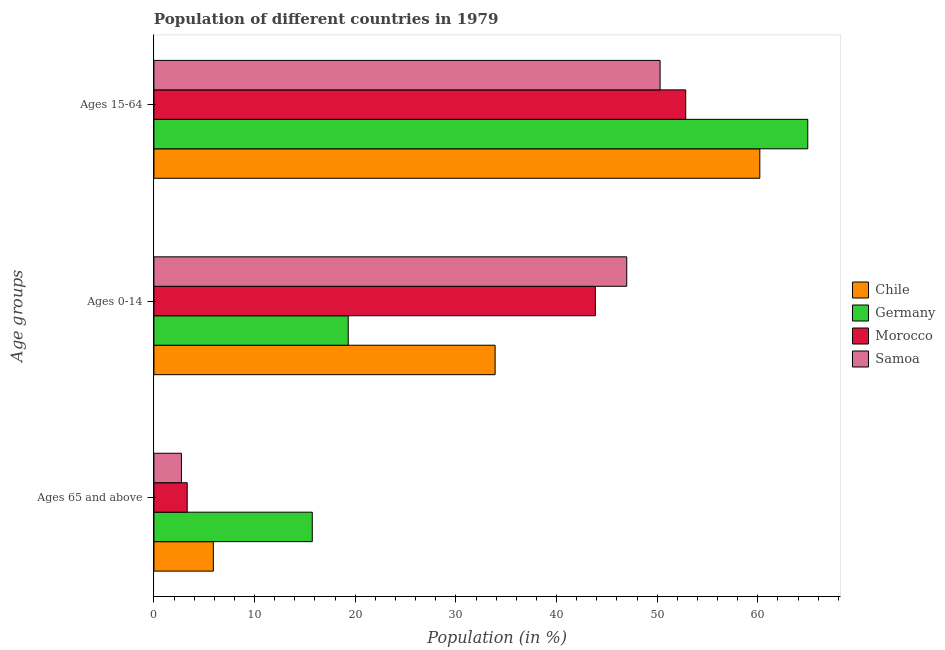How many different coloured bars are there?
Offer a very short reply. 4. Are the number of bars per tick equal to the number of legend labels?
Keep it short and to the point. Yes. How many bars are there on the 1st tick from the top?
Your answer should be very brief. 4. What is the label of the 3rd group of bars from the top?
Your answer should be compact. Ages 65 and above. What is the percentage of population within the age-group 0-14 in Morocco?
Keep it short and to the point. 43.86. Across all countries, what is the maximum percentage of population within the age-group of 65 and above?
Provide a short and direct response. 15.73. Across all countries, what is the minimum percentage of population within the age-group 15-64?
Your answer should be very brief. 50.29. In which country was the percentage of population within the age-group 0-14 maximum?
Provide a short and direct response. Samoa. What is the total percentage of population within the age-group 15-64 in the graph?
Ensure brevity in your answer.  228.28. What is the difference between the percentage of population within the age-group 15-64 in Chile and that in Morocco?
Your response must be concise. 7.36. What is the difference between the percentage of population within the age-group of 65 and above in Morocco and the percentage of population within the age-group 0-14 in Samoa?
Provide a short and direct response. -43.67. What is the average percentage of population within the age-group 0-14 per country?
Provide a succinct answer. 36.01. What is the difference between the percentage of population within the age-group of 65 and above and percentage of population within the age-group 0-14 in Germany?
Keep it short and to the point. -3.57. In how many countries, is the percentage of population within the age-group of 65 and above greater than 36 %?
Offer a terse response. 0. What is the ratio of the percentage of population within the age-group 0-14 in Chile to that in Samoa?
Give a very brief answer. 0.72. Is the difference between the percentage of population within the age-group 15-64 in Germany and Chile greater than the difference between the percentage of population within the age-group of 65 and above in Germany and Chile?
Ensure brevity in your answer.  No. What is the difference between the highest and the second highest percentage of population within the age-group of 65 and above?
Offer a very short reply. 9.83. What is the difference between the highest and the lowest percentage of population within the age-group 0-14?
Offer a very short reply. 27.67. In how many countries, is the percentage of population within the age-group 0-14 greater than the average percentage of population within the age-group 0-14 taken over all countries?
Ensure brevity in your answer.  2. Is the sum of the percentage of population within the age-group 15-64 in Chile and Germany greater than the maximum percentage of population within the age-group of 65 and above across all countries?
Make the answer very short. Yes. What does the 4th bar from the top in Ages 0-14 represents?
Ensure brevity in your answer.  Chile. How many bars are there?
Your answer should be very brief. 12. Are all the bars in the graph horizontal?
Provide a succinct answer. Yes. What is the difference between two consecutive major ticks on the X-axis?
Provide a short and direct response. 10. Where does the legend appear in the graph?
Make the answer very short. Center right. How are the legend labels stacked?
Keep it short and to the point. Vertical. What is the title of the graph?
Provide a short and direct response. Population of different countries in 1979. Does "Latin America(developing only)" appear as one of the legend labels in the graph?
Your response must be concise. No. What is the label or title of the Y-axis?
Keep it short and to the point. Age groups. What is the Population (in %) of Chile in Ages 65 and above?
Provide a short and direct response. 5.9. What is the Population (in %) in Germany in Ages 65 and above?
Your answer should be very brief. 15.73. What is the Population (in %) of Morocco in Ages 65 and above?
Your answer should be very brief. 3.31. What is the Population (in %) in Samoa in Ages 65 and above?
Your answer should be compact. 2.73. What is the Population (in %) in Chile in Ages 0-14?
Provide a short and direct response. 33.9. What is the Population (in %) in Germany in Ages 0-14?
Provide a succinct answer. 19.31. What is the Population (in %) in Morocco in Ages 0-14?
Provide a short and direct response. 43.86. What is the Population (in %) in Samoa in Ages 0-14?
Ensure brevity in your answer.  46.98. What is the Population (in %) of Chile in Ages 15-64?
Offer a very short reply. 60.2. What is the Population (in %) in Germany in Ages 15-64?
Provide a short and direct response. 64.96. What is the Population (in %) in Morocco in Ages 15-64?
Your answer should be compact. 52.83. What is the Population (in %) in Samoa in Ages 15-64?
Offer a very short reply. 50.29. Across all Age groups, what is the maximum Population (in %) of Chile?
Give a very brief answer. 60.2. Across all Age groups, what is the maximum Population (in %) in Germany?
Give a very brief answer. 64.96. Across all Age groups, what is the maximum Population (in %) of Morocco?
Offer a terse response. 52.83. Across all Age groups, what is the maximum Population (in %) in Samoa?
Ensure brevity in your answer.  50.29. Across all Age groups, what is the minimum Population (in %) of Chile?
Offer a very short reply. 5.9. Across all Age groups, what is the minimum Population (in %) in Germany?
Your answer should be very brief. 15.73. Across all Age groups, what is the minimum Population (in %) of Morocco?
Offer a terse response. 3.31. Across all Age groups, what is the minimum Population (in %) in Samoa?
Provide a succinct answer. 2.73. What is the total Population (in %) of Chile in the graph?
Your answer should be compact. 100. What is the total Population (in %) in Germany in the graph?
Ensure brevity in your answer.  100. What is the total Population (in %) of Morocco in the graph?
Give a very brief answer. 100. What is the total Population (in %) of Samoa in the graph?
Provide a succinct answer. 100. What is the difference between the Population (in %) of Chile in Ages 65 and above and that in Ages 0-14?
Ensure brevity in your answer.  -28. What is the difference between the Population (in %) of Germany in Ages 65 and above and that in Ages 0-14?
Make the answer very short. -3.57. What is the difference between the Population (in %) of Morocco in Ages 65 and above and that in Ages 0-14?
Your answer should be very brief. -40.55. What is the difference between the Population (in %) in Samoa in Ages 65 and above and that in Ages 0-14?
Offer a terse response. -44.24. What is the difference between the Population (in %) in Chile in Ages 65 and above and that in Ages 15-64?
Keep it short and to the point. -54.29. What is the difference between the Population (in %) of Germany in Ages 65 and above and that in Ages 15-64?
Keep it short and to the point. -49.23. What is the difference between the Population (in %) in Morocco in Ages 65 and above and that in Ages 15-64?
Keep it short and to the point. -49.53. What is the difference between the Population (in %) in Samoa in Ages 65 and above and that in Ages 15-64?
Keep it short and to the point. -47.56. What is the difference between the Population (in %) in Chile in Ages 0-14 and that in Ages 15-64?
Your answer should be very brief. -26.3. What is the difference between the Population (in %) in Germany in Ages 0-14 and that in Ages 15-64?
Offer a terse response. -45.66. What is the difference between the Population (in %) of Morocco in Ages 0-14 and that in Ages 15-64?
Your response must be concise. -8.98. What is the difference between the Population (in %) of Samoa in Ages 0-14 and that in Ages 15-64?
Give a very brief answer. -3.32. What is the difference between the Population (in %) of Chile in Ages 65 and above and the Population (in %) of Germany in Ages 0-14?
Ensure brevity in your answer.  -13.4. What is the difference between the Population (in %) of Chile in Ages 65 and above and the Population (in %) of Morocco in Ages 0-14?
Provide a succinct answer. -37.96. What is the difference between the Population (in %) in Chile in Ages 65 and above and the Population (in %) in Samoa in Ages 0-14?
Your answer should be very brief. -41.07. What is the difference between the Population (in %) in Germany in Ages 65 and above and the Population (in %) in Morocco in Ages 0-14?
Your answer should be compact. -28.13. What is the difference between the Population (in %) of Germany in Ages 65 and above and the Population (in %) of Samoa in Ages 0-14?
Your response must be concise. -31.24. What is the difference between the Population (in %) of Morocco in Ages 65 and above and the Population (in %) of Samoa in Ages 0-14?
Your answer should be very brief. -43.67. What is the difference between the Population (in %) of Chile in Ages 65 and above and the Population (in %) of Germany in Ages 15-64?
Your answer should be very brief. -59.06. What is the difference between the Population (in %) in Chile in Ages 65 and above and the Population (in %) in Morocco in Ages 15-64?
Your answer should be very brief. -46.93. What is the difference between the Population (in %) of Chile in Ages 65 and above and the Population (in %) of Samoa in Ages 15-64?
Give a very brief answer. -44.39. What is the difference between the Population (in %) in Germany in Ages 65 and above and the Population (in %) in Morocco in Ages 15-64?
Provide a short and direct response. -37.1. What is the difference between the Population (in %) of Germany in Ages 65 and above and the Population (in %) of Samoa in Ages 15-64?
Your answer should be compact. -34.56. What is the difference between the Population (in %) in Morocco in Ages 65 and above and the Population (in %) in Samoa in Ages 15-64?
Your answer should be very brief. -46.98. What is the difference between the Population (in %) in Chile in Ages 0-14 and the Population (in %) in Germany in Ages 15-64?
Keep it short and to the point. -31.06. What is the difference between the Population (in %) in Chile in Ages 0-14 and the Population (in %) in Morocco in Ages 15-64?
Offer a terse response. -18.94. What is the difference between the Population (in %) of Chile in Ages 0-14 and the Population (in %) of Samoa in Ages 15-64?
Ensure brevity in your answer.  -16.39. What is the difference between the Population (in %) of Germany in Ages 0-14 and the Population (in %) of Morocco in Ages 15-64?
Your response must be concise. -33.53. What is the difference between the Population (in %) of Germany in Ages 0-14 and the Population (in %) of Samoa in Ages 15-64?
Give a very brief answer. -30.99. What is the difference between the Population (in %) in Morocco in Ages 0-14 and the Population (in %) in Samoa in Ages 15-64?
Offer a terse response. -6.43. What is the average Population (in %) of Chile per Age groups?
Ensure brevity in your answer.  33.33. What is the average Population (in %) of Germany per Age groups?
Offer a terse response. 33.33. What is the average Population (in %) of Morocco per Age groups?
Your answer should be very brief. 33.33. What is the average Population (in %) of Samoa per Age groups?
Offer a terse response. 33.33. What is the difference between the Population (in %) of Chile and Population (in %) of Germany in Ages 65 and above?
Ensure brevity in your answer.  -9.83. What is the difference between the Population (in %) in Chile and Population (in %) in Morocco in Ages 65 and above?
Provide a succinct answer. 2.6. What is the difference between the Population (in %) in Chile and Population (in %) in Samoa in Ages 65 and above?
Offer a very short reply. 3.17. What is the difference between the Population (in %) of Germany and Population (in %) of Morocco in Ages 65 and above?
Make the answer very short. 12.43. What is the difference between the Population (in %) of Germany and Population (in %) of Samoa in Ages 65 and above?
Make the answer very short. 13. What is the difference between the Population (in %) of Morocco and Population (in %) of Samoa in Ages 65 and above?
Keep it short and to the point. 0.57. What is the difference between the Population (in %) in Chile and Population (in %) in Germany in Ages 0-14?
Provide a short and direct response. 14.59. What is the difference between the Population (in %) of Chile and Population (in %) of Morocco in Ages 0-14?
Ensure brevity in your answer.  -9.96. What is the difference between the Population (in %) in Chile and Population (in %) in Samoa in Ages 0-14?
Your answer should be very brief. -13.08. What is the difference between the Population (in %) of Germany and Population (in %) of Morocco in Ages 0-14?
Provide a short and direct response. -24.55. What is the difference between the Population (in %) of Germany and Population (in %) of Samoa in Ages 0-14?
Your answer should be compact. -27.67. What is the difference between the Population (in %) in Morocco and Population (in %) in Samoa in Ages 0-14?
Provide a short and direct response. -3.12. What is the difference between the Population (in %) in Chile and Population (in %) in Germany in Ages 15-64?
Offer a terse response. -4.76. What is the difference between the Population (in %) in Chile and Population (in %) in Morocco in Ages 15-64?
Provide a succinct answer. 7.36. What is the difference between the Population (in %) of Chile and Population (in %) of Samoa in Ages 15-64?
Keep it short and to the point. 9.91. What is the difference between the Population (in %) in Germany and Population (in %) in Morocco in Ages 15-64?
Keep it short and to the point. 12.13. What is the difference between the Population (in %) in Germany and Population (in %) in Samoa in Ages 15-64?
Offer a very short reply. 14.67. What is the difference between the Population (in %) in Morocco and Population (in %) in Samoa in Ages 15-64?
Provide a succinct answer. 2.54. What is the ratio of the Population (in %) in Chile in Ages 65 and above to that in Ages 0-14?
Keep it short and to the point. 0.17. What is the ratio of the Population (in %) in Germany in Ages 65 and above to that in Ages 0-14?
Give a very brief answer. 0.81. What is the ratio of the Population (in %) of Morocco in Ages 65 and above to that in Ages 0-14?
Give a very brief answer. 0.08. What is the ratio of the Population (in %) of Samoa in Ages 65 and above to that in Ages 0-14?
Offer a very short reply. 0.06. What is the ratio of the Population (in %) of Chile in Ages 65 and above to that in Ages 15-64?
Ensure brevity in your answer.  0.1. What is the ratio of the Population (in %) in Germany in Ages 65 and above to that in Ages 15-64?
Your answer should be compact. 0.24. What is the ratio of the Population (in %) of Morocco in Ages 65 and above to that in Ages 15-64?
Your answer should be compact. 0.06. What is the ratio of the Population (in %) of Samoa in Ages 65 and above to that in Ages 15-64?
Give a very brief answer. 0.05. What is the ratio of the Population (in %) in Chile in Ages 0-14 to that in Ages 15-64?
Provide a succinct answer. 0.56. What is the ratio of the Population (in %) of Germany in Ages 0-14 to that in Ages 15-64?
Ensure brevity in your answer.  0.3. What is the ratio of the Population (in %) in Morocco in Ages 0-14 to that in Ages 15-64?
Ensure brevity in your answer.  0.83. What is the ratio of the Population (in %) in Samoa in Ages 0-14 to that in Ages 15-64?
Make the answer very short. 0.93. What is the difference between the highest and the second highest Population (in %) of Chile?
Keep it short and to the point. 26.3. What is the difference between the highest and the second highest Population (in %) of Germany?
Keep it short and to the point. 45.66. What is the difference between the highest and the second highest Population (in %) in Morocco?
Your response must be concise. 8.98. What is the difference between the highest and the second highest Population (in %) of Samoa?
Your answer should be very brief. 3.32. What is the difference between the highest and the lowest Population (in %) of Chile?
Your answer should be compact. 54.29. What is the difference between the highest and the lowest Population (in %) of Germany?
Provide a short and direct response. 49.23. What is the difference between the highest and the lowest Population (in %) of Morocco?
Make the answer very short. 49.53. What is the difference between the highest and the lowest Population (in %) of Samoa?
Keep it short and to the point. 47.56. 